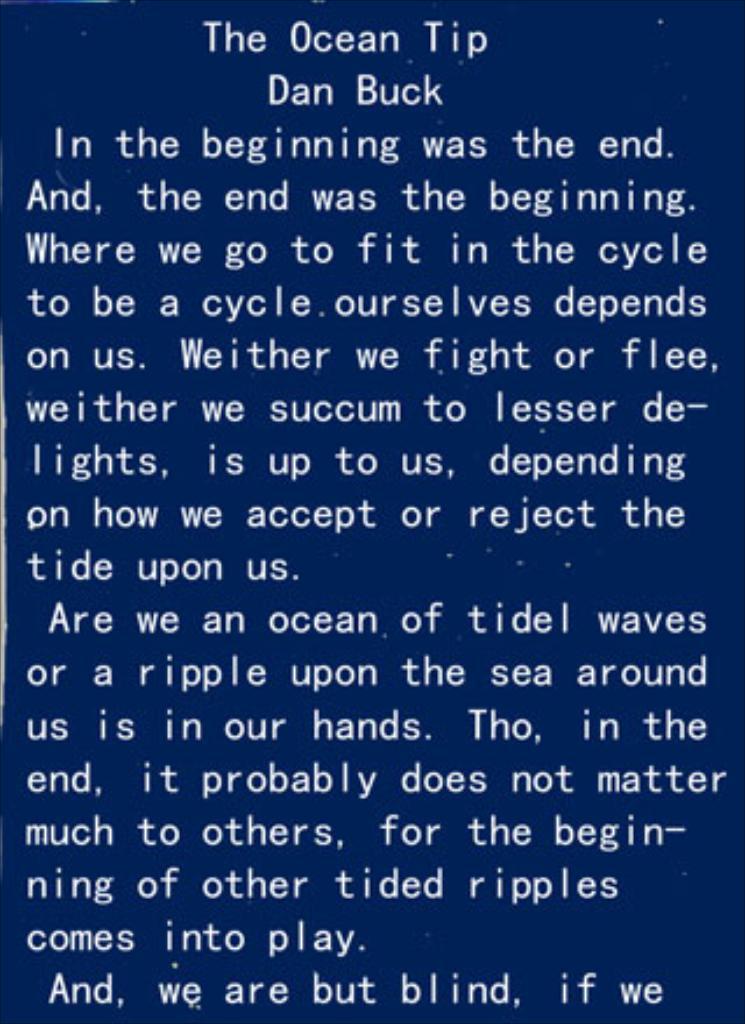Who is the author of the passage?
Ensure brevity in your answer.  Dan buck. What is the title of this piece?
Make the answer very short. The ocean tip. 